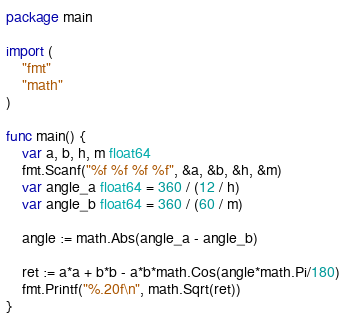<code> <loc_0><loc_0><loc_500><loc_500><_Go_>package main

import (
	"fmt"
	"math"
)

func main() {
	var a, b, h, m float64
	fmt.Scanf("%f %f %f %f", &a, &b, &h, &m)
	var angle_a float64 = 360 / (12 / h)
	var angle_b float64 = 360 / (60 / m)

	angle := math.Abs(angle_a - angle_b)

	ret := a*a + b*b - a*b*math.Cos(angle*math.Pi/180)
	fmt.Printf("%.20f\n", math.Sqrt(ret))
}
</code> 